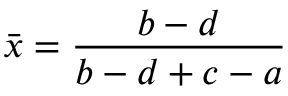<formula> <loc_0><loc_0><loc_500><loc_500>\bar { x } = \frac { b - d } { b - d + c - a }</formula> 